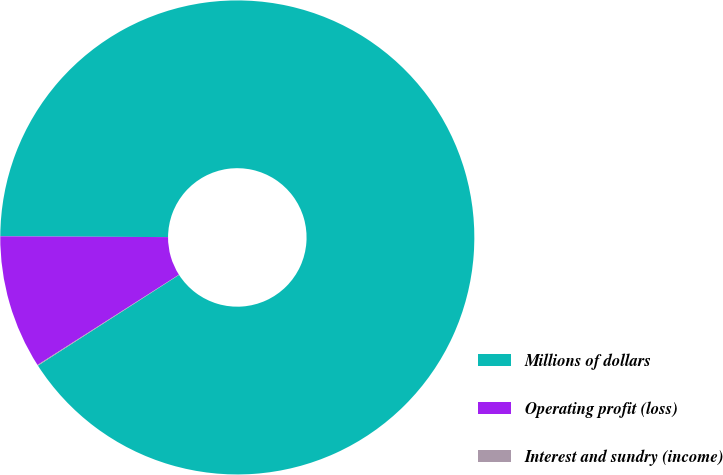Convert chart to OTSL. <chart><loc_0><loc_0><loc_500><loc_500><pie_chart><fcel>Millions of dollars<fcel>Operating profit (loss)<fcel>Interest and sundry (income)<nl><fcel>90.83%<fcel>9.12%<fcel>0.05%<nl></chart> 